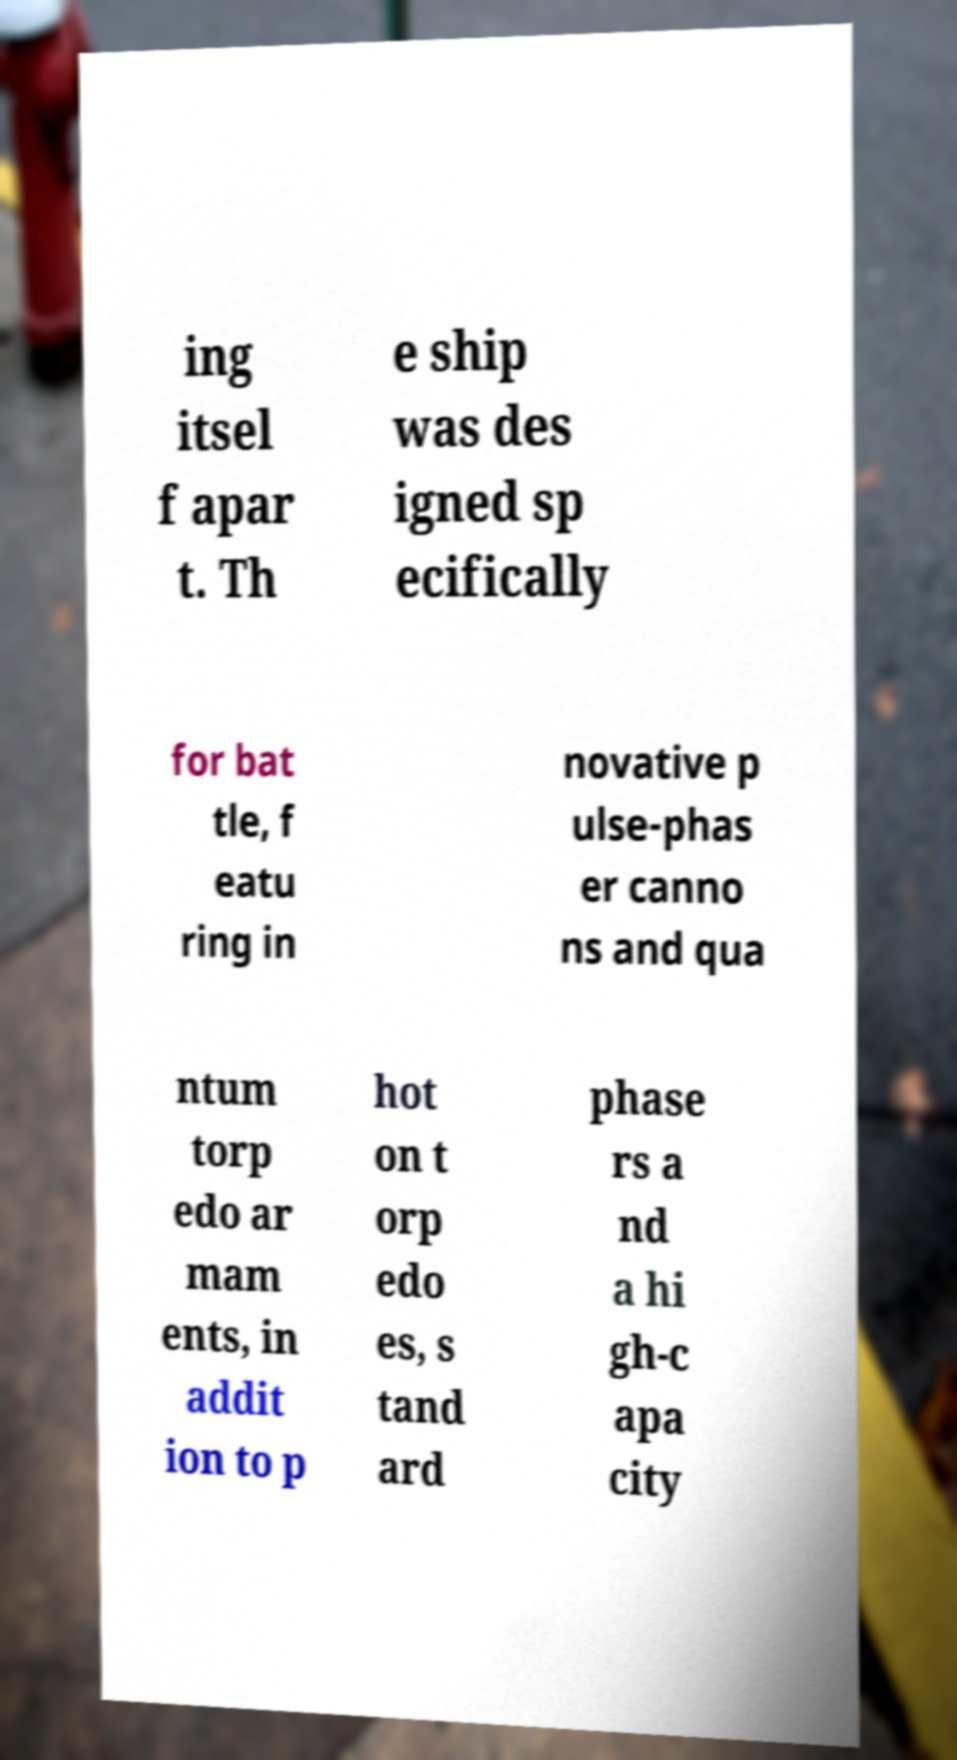For documentation purposes, I need the text within this image transcribed. Could you provide that? ing itsel f apar t. Th e ship was des igned sp ecifically for bat tle, f eatu ring in novative p ulse-phas er canno ns and qua ntum torp edo ar mam ents, in addit ion to p hot on t orp edo es, s tand ard phase rs a nd a hi gh-c apa city 